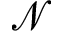<formula> <loc_0><loc_0><loc_500><loc_500>\mathcal { N }</formula> 